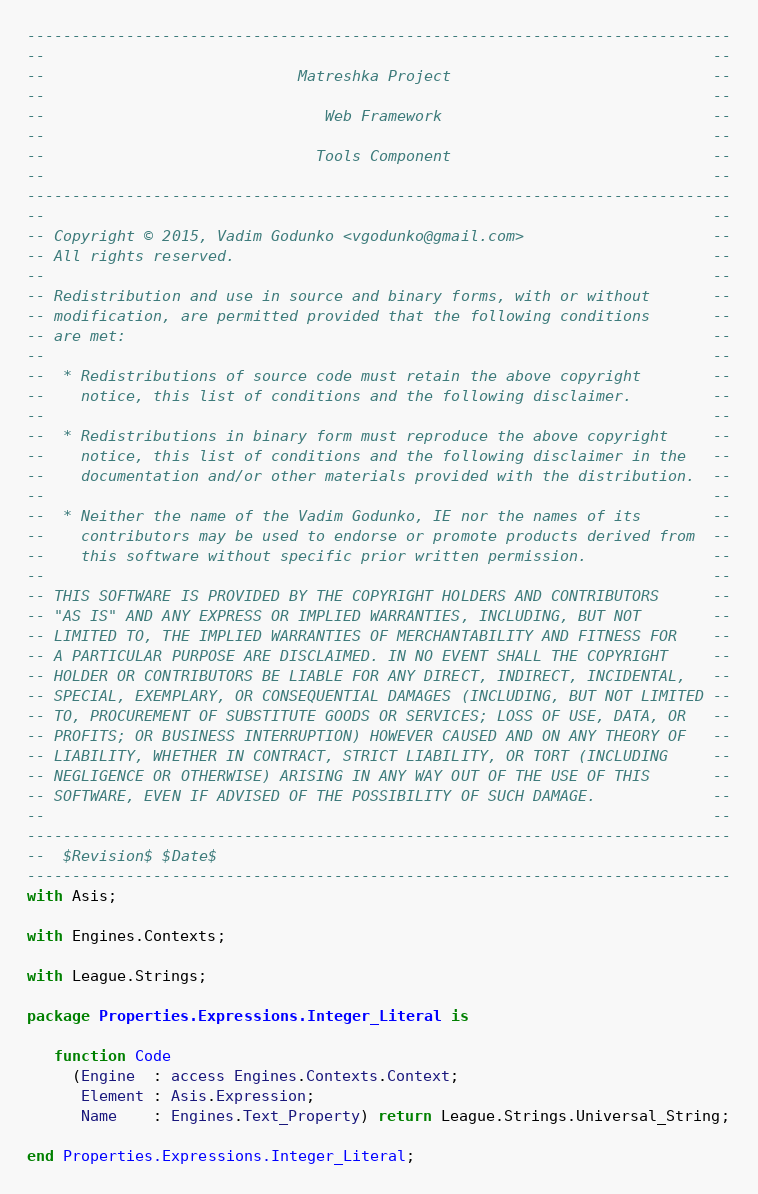Convert code to text. <code><loc_0><loc_0><loc_500><loc_500><_Ada_>------------------------------------------------------------------------------
--                                                                          --
--                            Matreshka Project                             --
--                                                                          --
--                               Web Framework                              --
--                                                                          --
--                              Tools Component                             --
--                                                                          --
------------------------------------------------------------------------------
--                                                                          --
-- Copyright © 2015, Vadim Godunko <vgodunko@gmail.com>                     --
-- All rights reserved.                                                     --
--                                                                          --
-- Redistribution and use in source and binary forms, with or without       --
-- modification, are permitted provided that the following conditions       --
-- are met:                                                                 --
--                                                                          --
--  * Redistributions of source code must retain the above copyright        --
--    notice, this list of conditions and the following disclaimer.         --
--                                                                          --
--  * Redistributions in binary form must reproduce the above copyright     --
--    notice, this list of conditions and the following disclaimer in the   --
--    documentation and/or other materials provided with the distribution.  --
--                                                                          --
--  * Neither the name of the Vadim Godunko, IE nor the names of its        --
--    contributors may be used to endorse or promote products derived from  --
--    this software without specific prior written permission.              --
--                                                                          --
-- THIS SOFTWARE IS PROVIDED BY THE COPYRIGHT HOLDERS AND CONTRIBUTORS      --
-- "AS IS" AND ANY EXPRESS OR IMPLIED WARRANTIES, INCLUDING, BUT NOT        --
-- LIMITED TO, THE IMPLIED WARRANTIES OF MERCHANTABILITY AND FITNESS FOR    --
-- A PARTICULAR PURPOSE ARE DISCLAIMED. IN NO EVENT SHALL THE COPYRIGHT     --
-- HOLDER OR CONTRIBUTORS BE LIABLE FOR ANY DIRECT, INDIRECT, INCIDENTAL,   --
-- SPECIAL, EXEMPLARY, OR CONSEQUENTIAL DAMAGES (INCLUDING, BUT NOT LIMITED --
-- TO, PROCUREMENT OF SUBSTITUTE GOODS OR SERVICES; LOSS OF USE, DATA, OR   --
-- PROFITS; OR BUSINESS INTERRUPTION) HOWEVER CAUSED AND ON ANY THEORY OF   --
-- LIABILITY, WHETHER IN CONTRACT, STRICT LIABILITY, OR TORT (INCLUDING     --
-- NEGLIGENCE OR OTHERWISE) ARISING IN ANY WAY OUT OF THE USE OF THIS       --
-- SOFTWARE, EVEN IF ADVISED OF THE POSSIBILITY OF SUCH DAMAGE.             --
--                                                                          --
------------------------------------------------------------------------------
--  $Revision$ $Date$
------------------------------------------------------------------------------
with Asis;

with Engines.Contexts;

with League.Strings;

package Properties.Expressions.Integer_Literal is

   function Code
     (Engine  : access Engines.Contexts.Context;
      Element : Asis.Expression;
      Name    : Engines.Text_Property) return League.Strings.Universal_String;

end Properties.Expressions.Integer_Literal;
</code> 